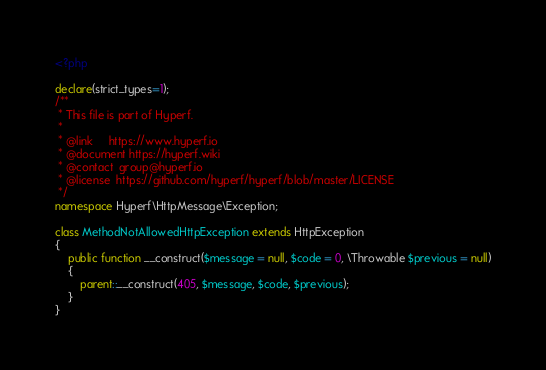Convert code to text. <code><loc_0><loc_0><loc_500><loc_500><_PHP_><?php

declare(strict_types=1);
/**
 * This file is part of Hyperf.
 *
 * @link     https://www.hyperf.io
 * @document https://hyperf.wiki
 * @contact  group@hyperf.io
 * @license  https://github.com/hyperf/hyperf/blob/master/LICENSE
 */
namespace Hyperf\HttpMessage\Exception;

class MethodNotAllowedHttpException extends HttpException
{
    public function __construct($message = null, $code = 0, \Throwable $previous = null)
    {
        parent::__construct(405, $message, $code, $previous);
    }
}
</code> 